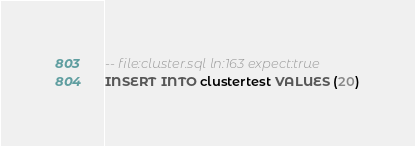<code> <loc_0><loc_0><loc_500><loc_500><_SQL_>-- file:cluster.sql ln:163 expect:true
INSERT INTO clustertest VALUES (20)
</code> 